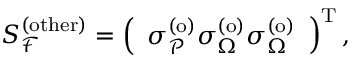Convert formula to latex. <formula><loc_0><loc_0><loc_500><loc_500>S _ { \mathcal { F } } ^ { ( o t h e r ) } = \left ( \begin{array} { l } { \sigma _ { \mathcal { P } } ^ { ( o ) } \sigma _ { \Omega } ^ { ( o ) } \sigma _ { \Omega } ^ { ( o ) } } \end{array} \right ) ^ { T } ,</formula> 